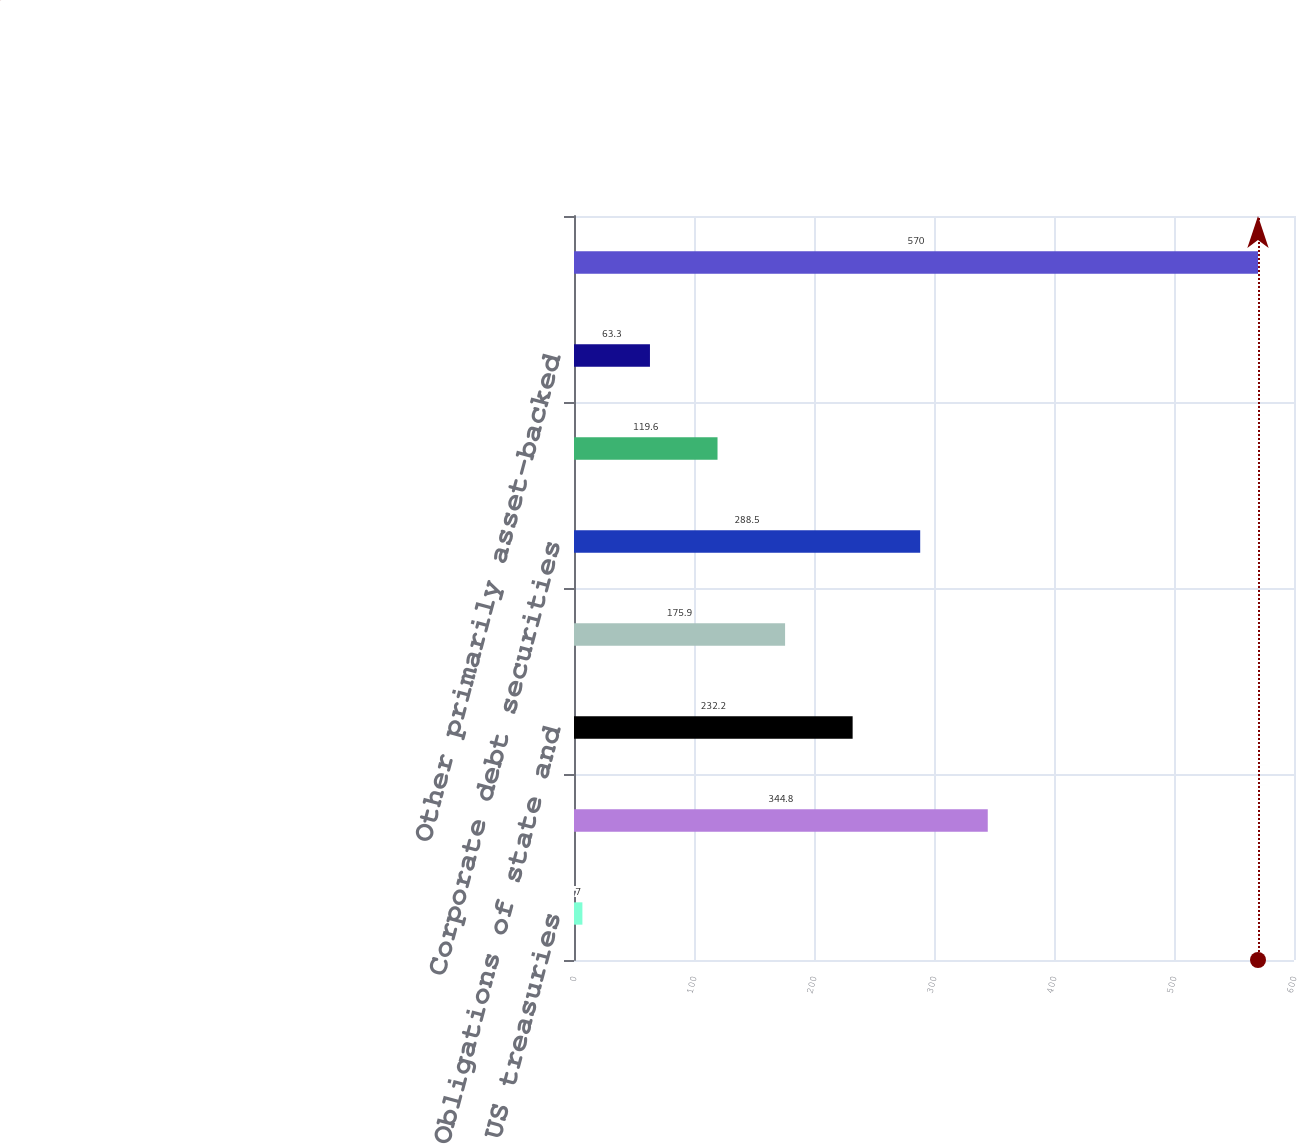Convert chart to OTSL. <chart><loc_0><loc_0><loc_500><loc_500><bar_chart><fcel>US treasuries<fcel>US government-sponsored<fcel>Obligations of state and<fcel>Debt securities issued by<fcel>Corporate debt securities<fcel>Equity securities<fcel>Other primarily asset-backed<fcel>Total available-for-sale<nl><fcel>7<fcel>344.8<fcel>232.2<fcel>175.9<fcel>288.5<fcel>119.6<fcel>63.3<fcel>570<nl></chart> 